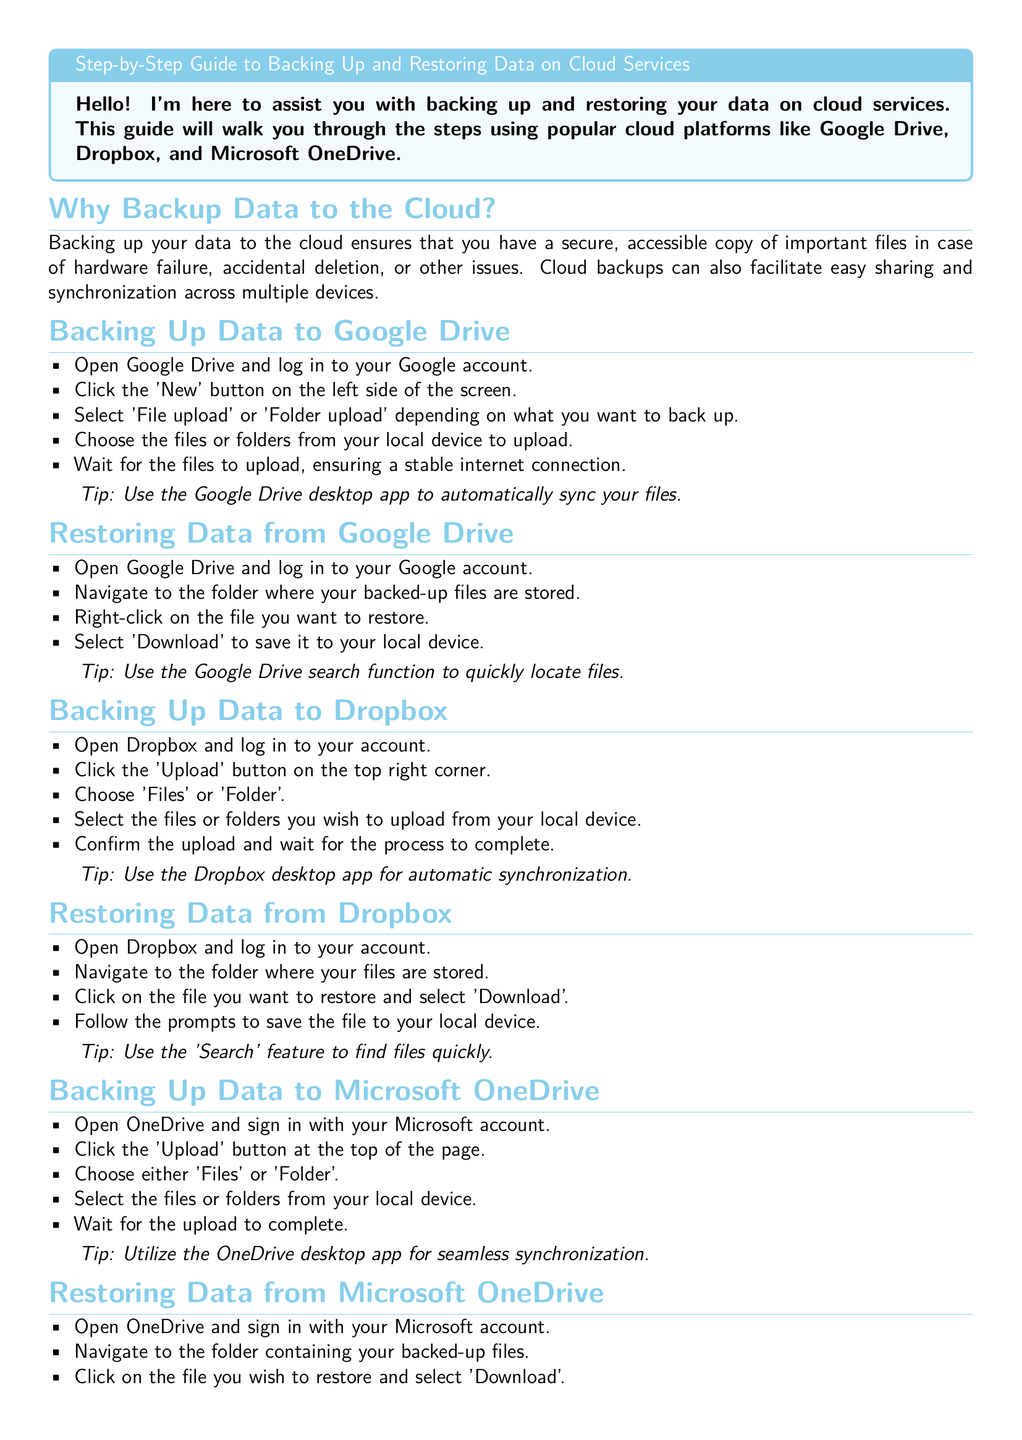What is the title of the guide? The title of the guide is specified at the beginning of the document.
Answer: Step-by-Step Guide to Backing Up and Restoring Data on Cloud Services How many cloud platforms are mentioned in the document? The document discusses three specific cloud platforms for backing up and restoring data.
Answer: Three What is the first step to back up data on Google Drive? The initial step for backing up data on Google Drive is clearly outlined in the listing.
Answer: Open Google Drive and log in to your Google account What should you ensure during the upload process on Google Drive? The document emphasizes a specific condition to be maintained during uploading.
Answer: A stable internet connection What is the last step to restore data from Dropbox? The last action described for restoring data from Dropbox outlines what to do after selecting the file.
Answer: Follow the prompts to save the file to your local device Which desktop app is recommended for Google Drive? The document provides a tip regarding a specific desktop application for Google Drive.
Answer: Google Drive desktop app What type of feature can help locate files quickly in Dropbox? The document suggests utilizing a specific functionality to enhance file searching.
Answer: Search feature What should you ensure before downloading files from OneDrive? There's a precautionary step mentioned regarding local device storage when restoring files.
Answer: Adequate storage space for downloads 